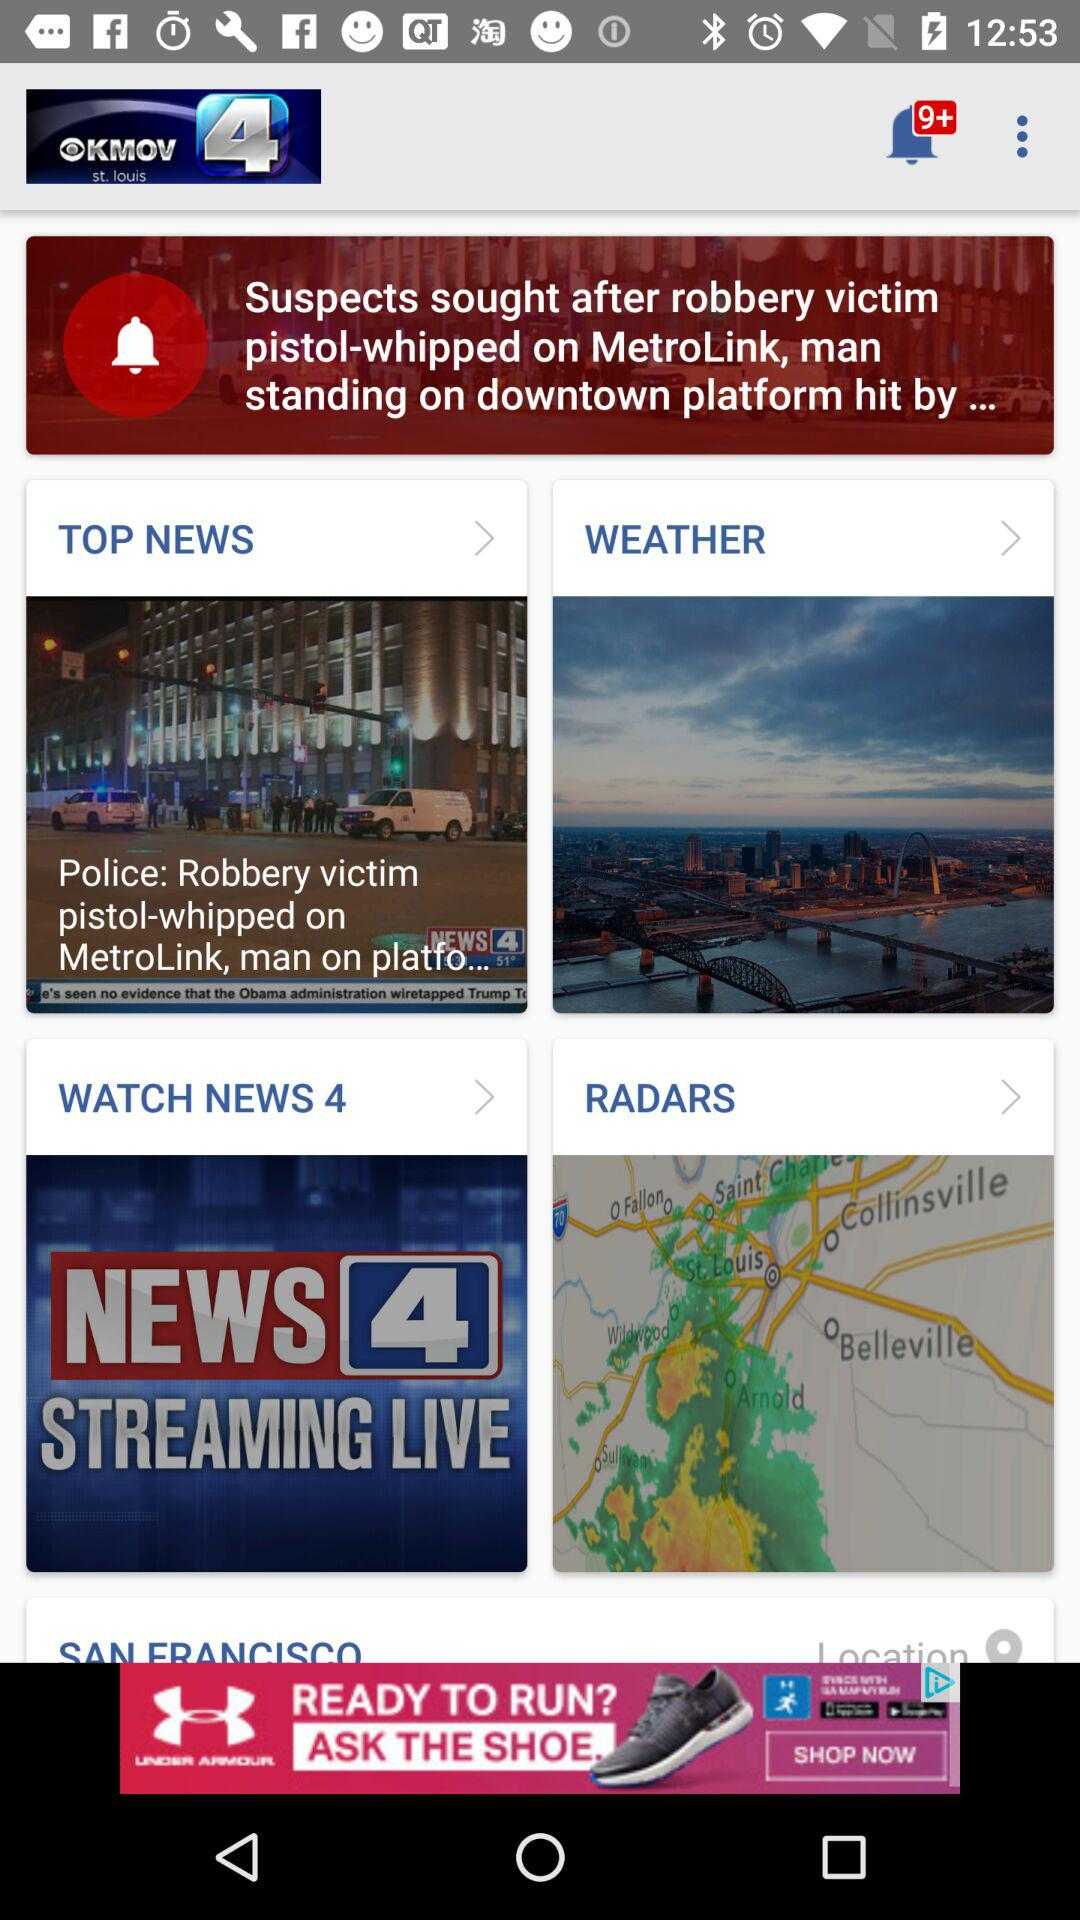How many unread messages are there in the notifications? There are 9+ unread messages in the notifications. 